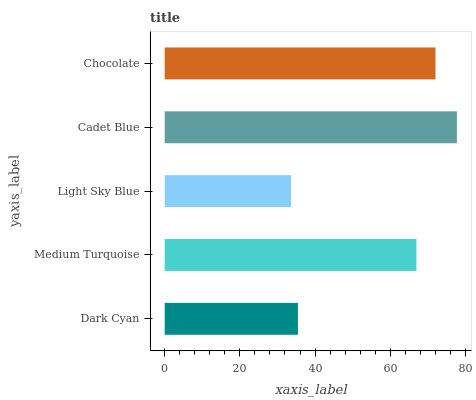Is Light Sky Blue the minimum?
Answer yes or no. Yes. Is Cadet Blue the maximum?
Answer yes or no. Yes. Is Medium Turquoise the minimum?
Answer yes or no. No. Is Medium Turquoise the maximum?
Answer yes or no. No. Is Medium Turquoise greater than Dark Cyan?
Answer yes or no. Yes. Is Dark Cyan less than Medium Turquoise?
Answer yes or no. Yes. Is Dark Cyan greater than Medium Turquoise?
Answer yes or no. No. Is Medium Turquoise less than Dark Cyan?
Answer yes or no. No. Is Medium Turquoise the high median?
Answer yes or no. Yes. Is Medium Turquoise the low median?
Answer yes or no. Yes. Is Cadet Blue the high median?
Answer yes or no. No. Is Dark Cyan the low median?
Answer yes or no. No. 